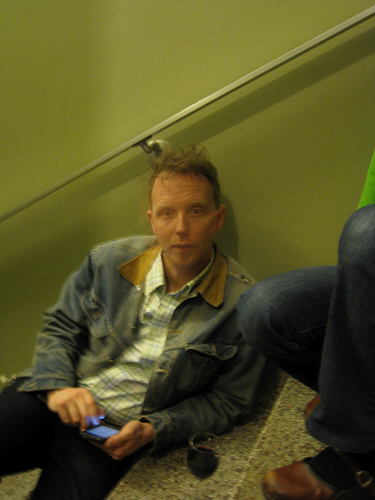<image>
Is there a cap in the man? No. The cap is not contained within the man. These objects have a different spatial relationship. Is the man behind the mobile? Yes. From this viewpoint, the man is positioned behind the mobile, with the mobile partially or fully occluding the man. Where is the shoes in relation to the man? Is it on the man? No. The shoes is not positioned on the man. They may be near each other, but the shoes is not supported by or resting on top of the man. 